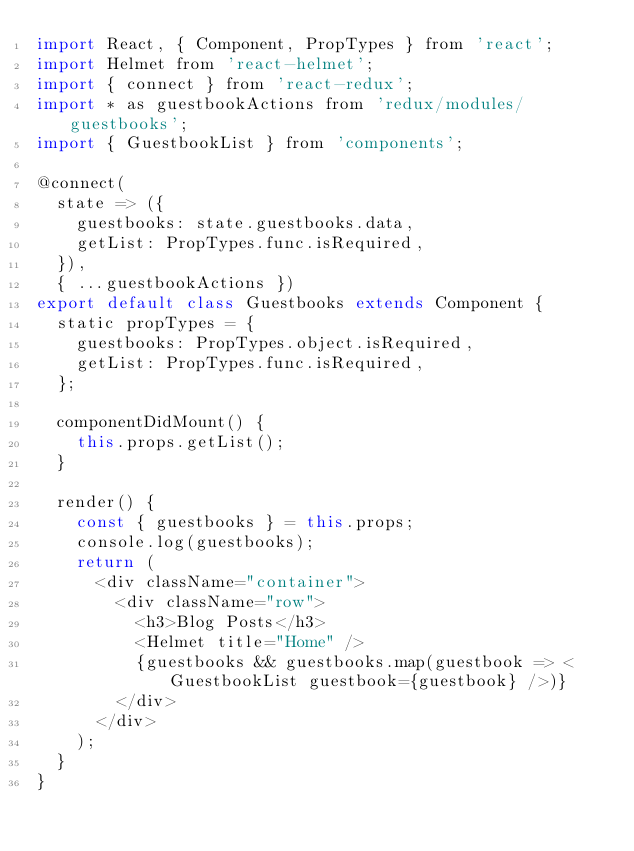Convert code to text. <code><loc_0><loc_0><loc_500><loc_500><_JavaScript_>import React, { Component, PropTypes } from 'react';
import Helmet from 'react-helmet';
import { connect } from 'react-redux';
import * as guestbookActions from 'redux/modules/guestbooks';
import { GuestbookList } from 'components';

@connect(
  state => ({
    guestbooks: state.guestbooks.data,
    getList: PropTypes.func.isRequired,
  }),
  { ...guestbookActions })
export default class Guestbooks extends Component {
  static propTypes = {
    guestbooks: PropTypes.object.isRequired,
    getList: PropTypes.func.isRequired,
  };

  componentDidMount() {
    this.props.getList();
  }

  render() {
    const { guestbooks } = this.props;
    console.log(guestbooks);
    return (
      <div className="container">
        <div className="row">
          <h3>Blog Posts</h3>
          <Helmet title="Home" />
          {guestbooks && guestbooks.map(guestbook => <GuestbookList guestbook={guestbook} />)}
        </div>
      </div>
    );
  }
}
</code> 